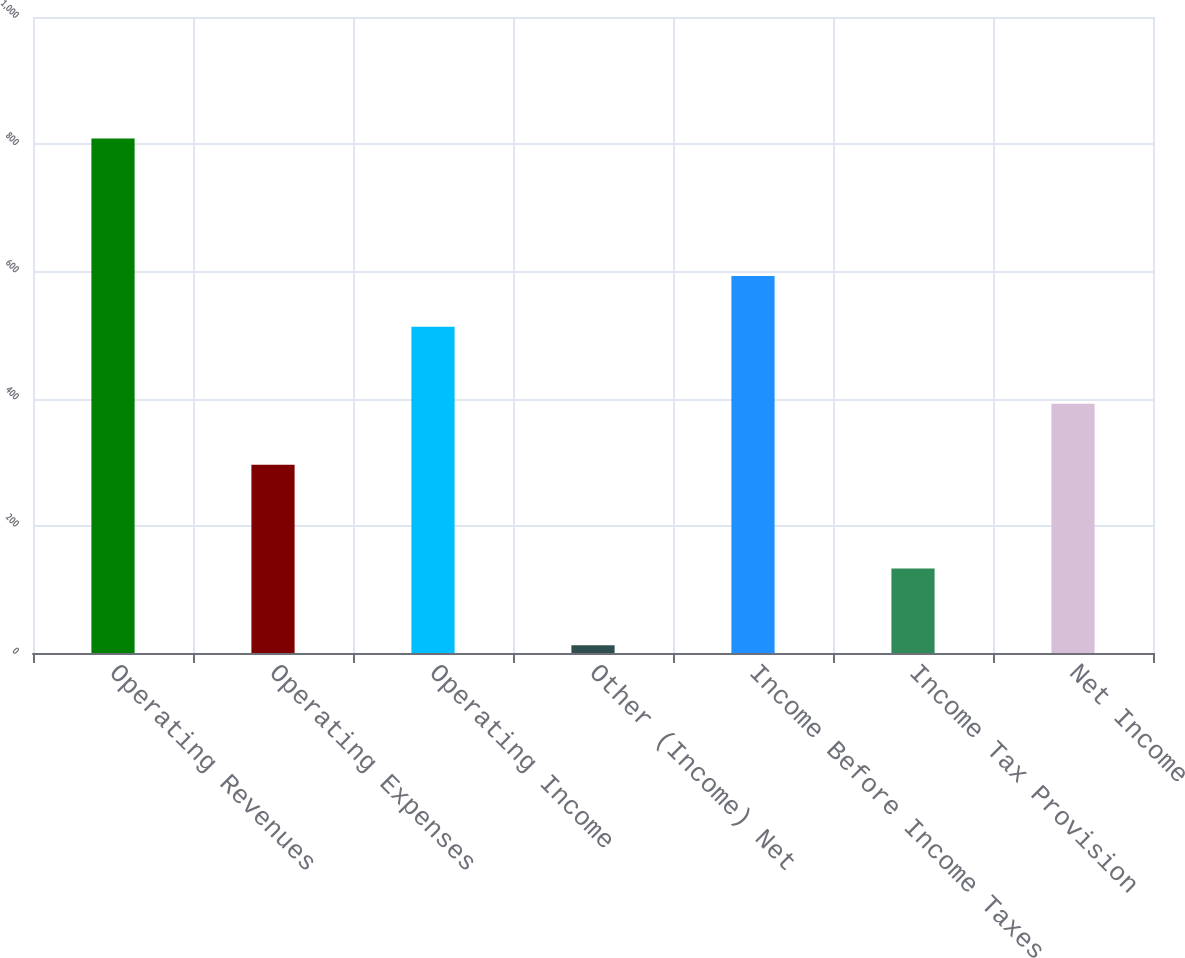Convert chart to OTSL. <chart><loc_0><loc_0><loc_500><loc_500><bar_chart><fcel>Operating Revenues<fcel>Operating Expenses<fcel>Operating Income<fcel>Other (Income) Net<fcel>Income Before Income Taxes<fcel>Income Tax Provision<fcel>Net Income<nl><fcel>809<fcel>296<fcel>513<fcel>12<fcel>592.7<fcel>133<fcel>392<nl></chart> 